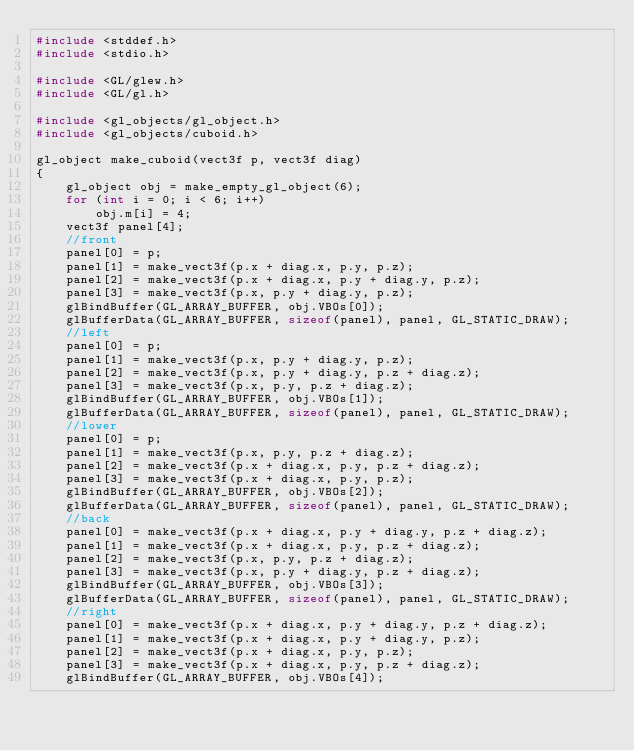<code> <loc_0><loc_0><loc_500><loc_500><_C_>#include <stddef.h>
#include <stdio.h>

#include <GL/glew.h>
#include <GL/gl.h>

#include <gl_objects/gl_object.h>
#include <gl_objects/cuboid.h>

gl_object make_cuboid(vect3f p, vect3f diag)
{
    gl_object obj = make_empty_gl_object(6);
    for (int i = 0; i < 6; i++)
        obj.m[i] = 4;
    vect3f panel[4];
    //front
    panel[0] = p;
    panel[1] = make_vect3f(p.x + diag.x, p.y, p.z);
    panel[2] = make_vect3f(p.x + diag.x, p.y + diag.y, p.z);
    panel[3] = make_vect3f(p.x, p.y + diag.y, p.z);
    glBindBuffer(GL_ARRAY_BUFFER, obj.VBOs[0]);
    glBufferData(GL_ARRAY_BUFFER, sizeof(panel), panel, GL_STATIC_DRAW);
    //left
    panel[0] = p;
    panel[1] = make_vect3f(p.x, p.y + diag.y, p.z);
    panel[2] = make_vect3f(p.x, p.y + diag.y, p.z + diag.z);
    panel[3] = make_vect3f(p.x, p.y, p.z + diag.z);
    glBindBuffer(GL_ARRAY_BUFFER, obj.VBOs[1]);
    glBufferData(GL_ARRAY_BUFFER, sizeof(panel), panel, GL_STATIC_DRAW);
    //lower
    panel[0] = p;
    panel[1] = make_vect3f(p.x, p.y, p.z + diag.z);
    panel[2] = make_vect3f(p.x + diag.x, p.y, p.z + diag.z);
    panel[3] = make_vect3f(p.x + diag.x, p.y, p.z);
    glBindBuffer(GL_ARRAY_BUFFER, obj.VBOs[2]);
    glBufferData(GL_ARRAY_BUFFER, sizeof(panel), panel, GL_STATIC_DRAW);
    //back
    panel[0] = make_vect3f(p.x + diag.x, p.y + diag.y, p.z + diag.z);
    panel[1] = make_vect3f(p.x + diag.x, p.y, p.z + diag.z);
    panel[2] = make_vect3f(p.x, p.y, p.z + diag.z);
    panel[3] = make_vect3f(p.x, p.y + diag.y, p.z + diag.z);
    glBindBuffer(GL_ARRAY_BUFFER, obj.VBOs[3]);
    glBufferData(GL_ARRAY_BUFFER, sizeof(panel), panel, GL_STATIC_DRAW);
    //right
    panel[0] = make_vect3f(p.x + diag.x, p.y + diag.y, p.z + diag.z);
    panel[1] = make_vect3f(p.x + diag.x, p.y + diag.y, p.z);
    panel[2] = make_vect3f(p.x + diag.x, p.y, p.z);
    panel[3] = make_vect3f(p.x + diag.x, p.y, p.z + diag.z);
    glBindBuffer(GL_ARRAY_BUFFER, obj.VBOs[4]);</code> 